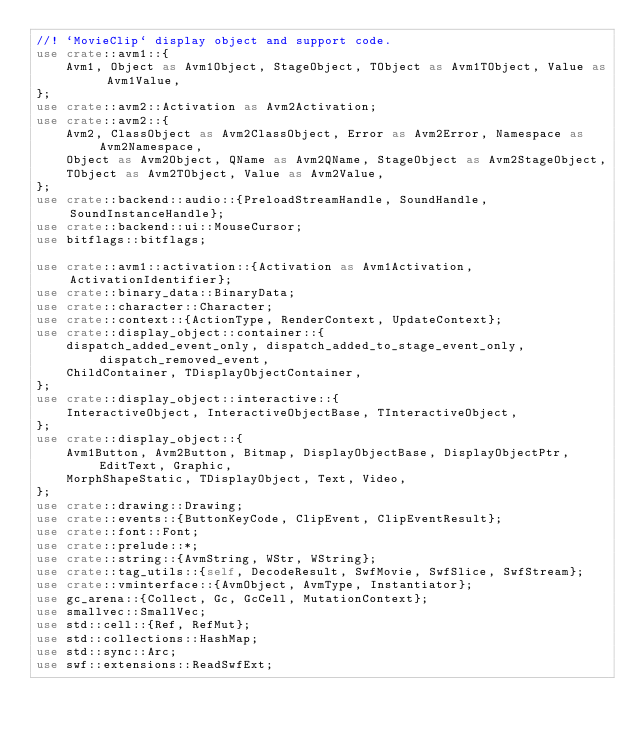Convert code to text. <code><loc_0><loc_0><loc_500><loc_500><_Rust_>//! `MovieClip` display object and support code.
use crate::avm1::{
    Avm1, Object as Avm1Object, StageObject, TObject as Avm1TObject, Value as Avm1Value,
};
use crate::avm2::Activation as Avm2Activation;
use crate::avm2::{
    Avm2, ClassObject as Avm2ClassObject, Error as Avm2Error, Namespace as Avm2Namespace,
    Object as Avm2Object, QName as Avm2QName, StageObject as Avm2StageObject,
    TObject as Avm2TObject, Value as Avm2Value,
};
use crate::backend::audio::{PreloadStreamHandle, SoundHandle, SoundInstanceHandle};
use crate::backend::ui::MouseCursor;
use bitflags::bitflags;

use crate::avm1::activation::{Activation as Avm1Activation, ActivationIdentifier};
use crate::binary_data::BinaryData;
use crate::character::Character;
use crate::context::{ActionType, RenderContext, UpdateContext};
use crate::display_object::container::{
    dispatch_added_event_only, dispatch_added_to_stage_event_only, dispatch_removed_event,
    ChildContainer, TDisplayObjectContainer,
};
use crate::display_object::interactive::{
    InteractiveObject, InteractiveObjectBase, TInteractiveObject,
};
use crate::display_object::{
    Avm1Button, Avm2Button, Bitmap, DisplayObjectBase, DisplayObjectPtr, EditText, Graphic,
    MorphShapeStatic, TDisplayObject, Text, Video,
};
use crate::drawing::Drawing;
use crate::events::{ButtonKeyCode, ClipEvent, ClipEventResult};
use crate::font::Font;
use crate::prelude::*;
use crate::string::{AvmString, WStr, WString};
use crate::tag_utils::{self, DecodeResult, SwfMovie, SwfSlice, SwfStream};
use crate::vminterface::{AvmObject, AvmType, Instantiator};
use gc_arena::{Collect, Gc, GcCell, MutationContext};
use smallvec::SmallVec;
use std::cell::{Ref, RefMut};
use std::collections::HashMap;
use std::sync::Arc;
use swf::extensions::ReadSwfExt;</code> 